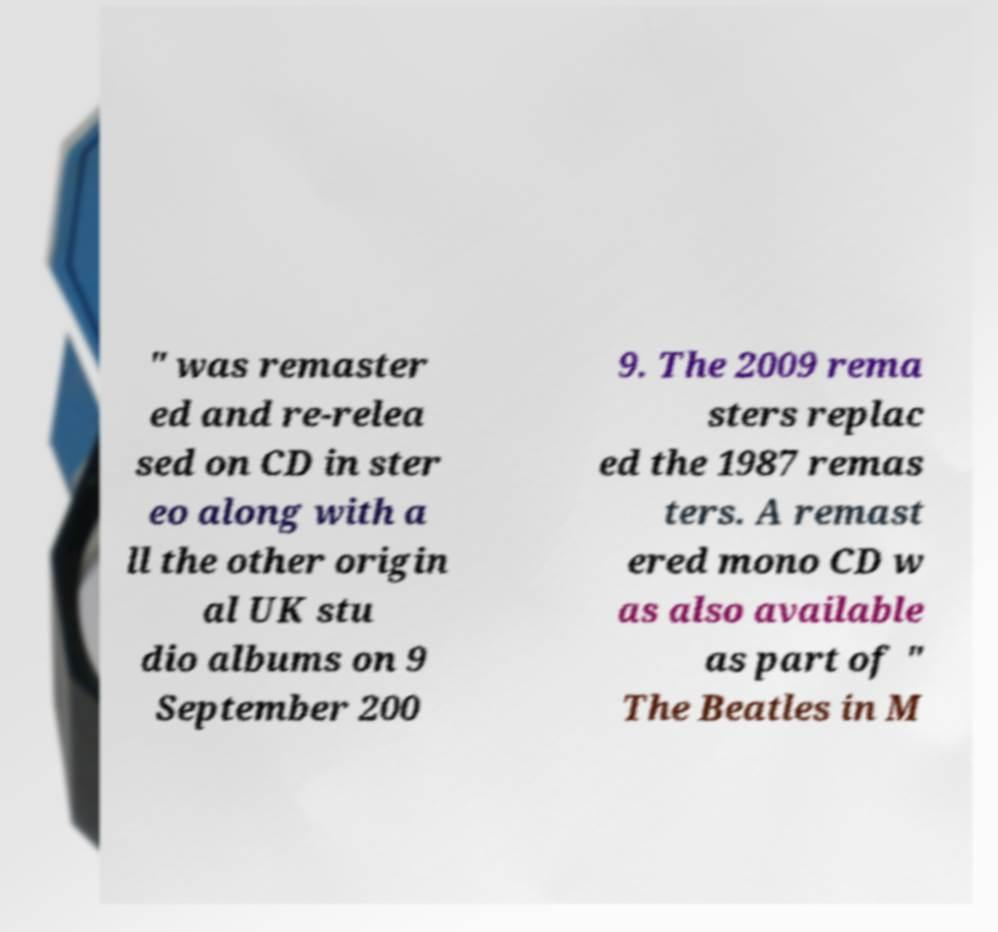There's text embedded in this image that I need extracted. Can you transcribe it verbatim? " was remaster ed and re-relea sed on CD in ster eo along with a ll the other origin al UK stu dio albums on 9 September 200 9. The 2009 rema sters replac ed the 1987 remas ters. A remast ered mono CD w as also available as part of " The Beatles in M 